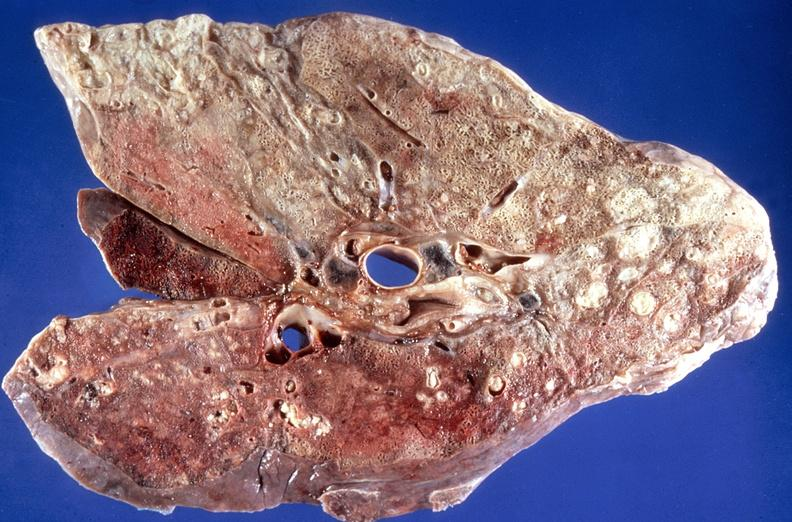what does this image show?
Answer the question using a single word or phrase. Lung 